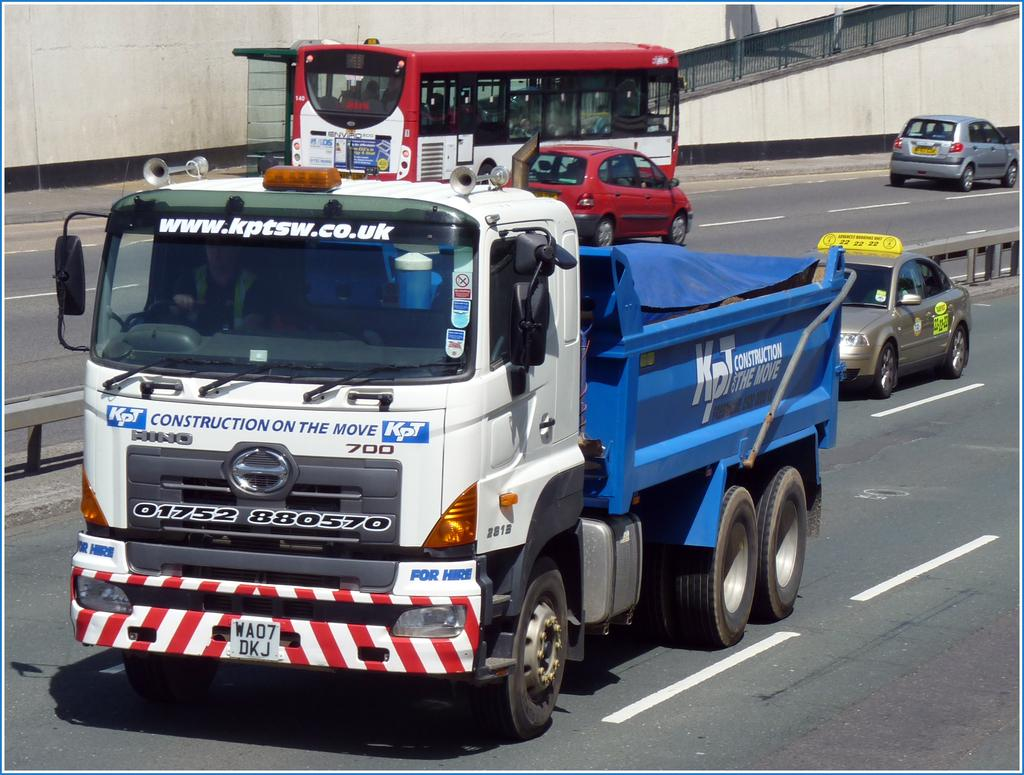<image>
Render a clear and concise summary of the photo. A blue and white KPT construction truck is driving down the road. 